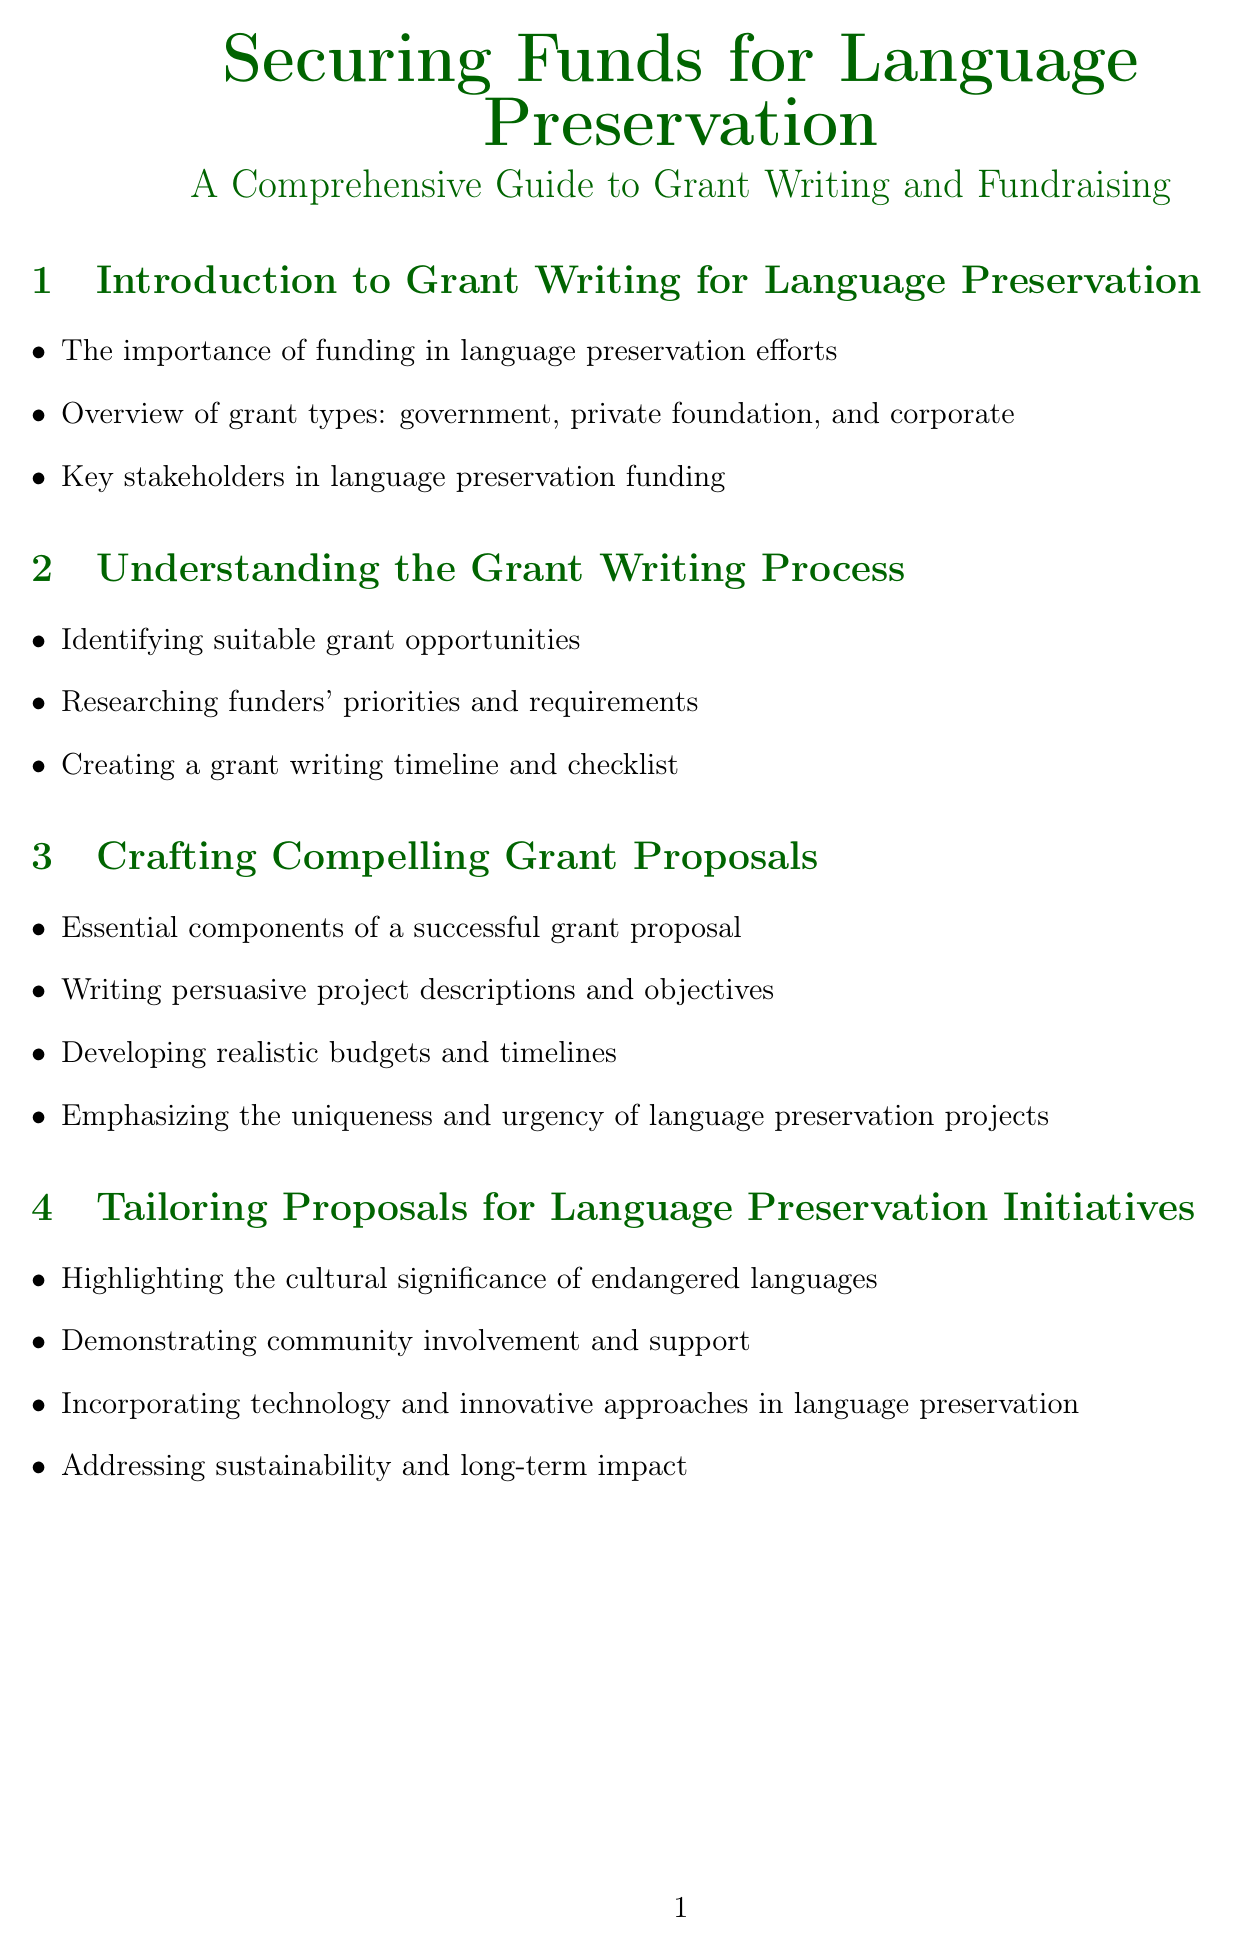What is the handbook title? The title is clearly stated at the beginning of the document, which is "Securing Funds for Language Preservation: A Comprehensive Guide to Grant Writing and Fundraising."
Answer: Securing Funds for Language Preservation: A Comprehensive Guide to Grant Writing and Fundraising How much funding was provided for the Ainu Language project? The document lists the amount of funding received for this specific project, which is stated as $250,000.
Answer: $250,000 What is included in the Executive Summary Template? The document provides an outline of what elements should be included in an Executive Summary Template, such as "Project title and organization name."
Answer: Project title and organization name Who funded the revitalization of Quechua in Peru? The document specifies the funder for this project, which is the National Geographic Society.
Answer: National Geographic Society What is the focus of the "Legal and Ethical Considerations" chapter? This chapter includes specific guidelines and considerations that are outlined, such as "Intellectual property rights in language documentation."
Answer: Intellectual property rights in language documentation How many grant proposal examples are provided in the handbook? The document highlights a total of two grant proposal examples in the section about successful proposals.
Answer: 2 What is one alternative fundraising strategy mentioned? The document lists various fundraising strategies and one example is "Crowdfunding campaigns for language preservation projects."
Answer: Crowdfunding campaigns for language preservation projects What are the key components of a Logic Model Template? The Logic Model Template includes defined components like "Inputs, Activities," and others, which are clearly outlined in the document.
Answer: Inputs, Activities What is emphasized in the "Tailoring Proposals for Language Preservation Initiatives" section? This section stresses the importance of incorporating community involvement, as stated in the bullet points, such as "Demonstrating community involvement and support."
Answer: Demonstrating community involvement and support 